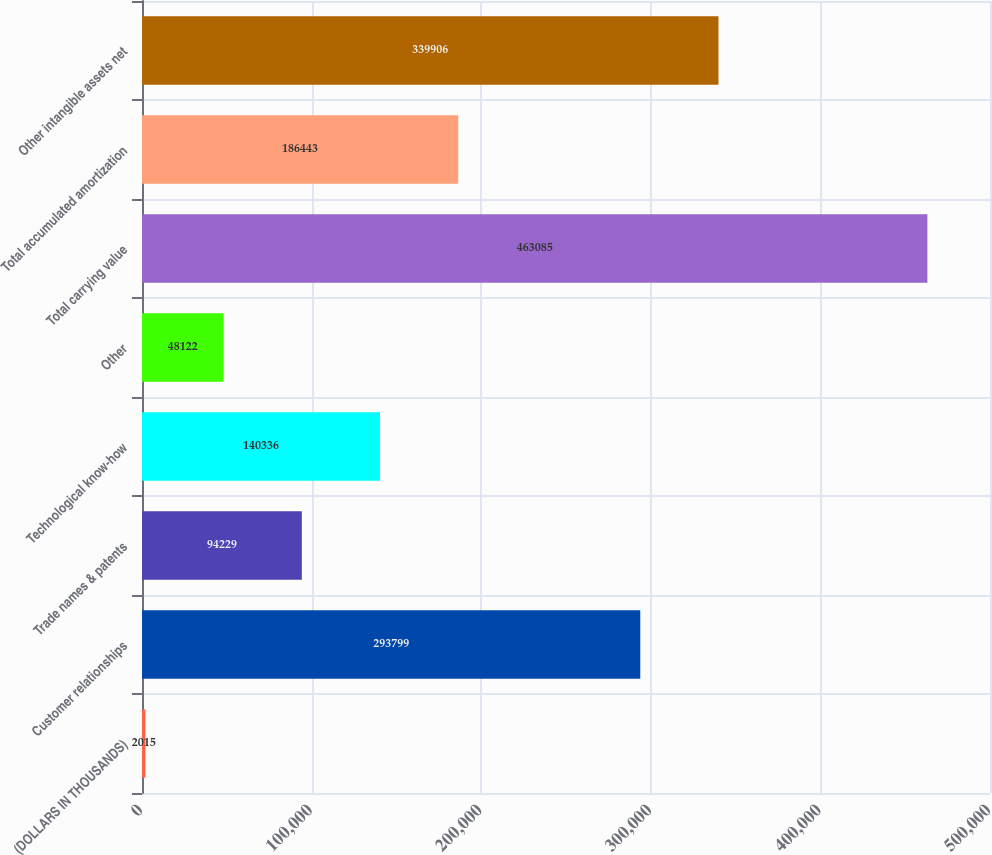<chart> <loc_0><loc_0><loc_500><loc_500><bar_chart><fcel>(DOLLARS IN THOUSANDS)<fcel>Customer relationships<fcel>Trade names & patents<fcel>Technological know-how<fcel>Other<fcel>Total carrying value<fcel>Total accumulated amortization<fcel>Other intangible assets net<nl><fcel>2015<fcel>293799<fcel>94229<fcel>140336<fcel>48122<fcel>463085<fcel>186443<fcel>339906<nl></chart> 